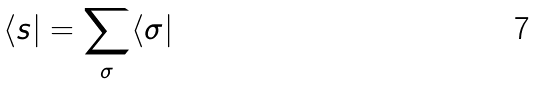<formula> <loc_0><loc_0><loc_500><loc_500>\langle s | = \sum _ { \sigma } \langle \sigma |</formula> 